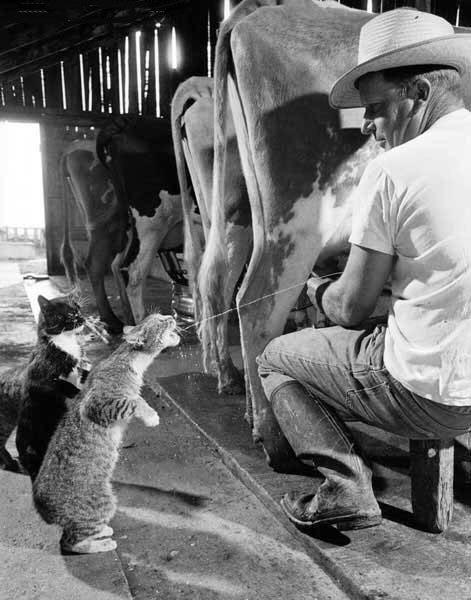How many cows are here?
Give a very brief answer. 4. How many cats are there?
Give a very brief answer. 2. How many cows can you see?
Give a very brief answer. 4. 